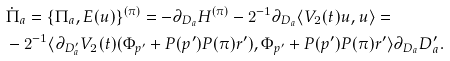<formula> <loc_0><loc_0><loc_500><loc_500>& \dot { \Pi } _ { a } = \{ \Pi _ { a } , E ( u ) \} ^ { ( \pi ) } = - { \partial _ { D _ { a } } } H ^ { ( \pi ) } - 2 ^ { - 1 } \partial _ { D _ { a } } \langle V _ { 2 } ( t ) u , u \rangle = \\ & - 2 ^ { - 1 } \langle \partial _ { D _ { a } ^ { \prime } } V _ { 2 } ( t ) ( \Phi _ { p ^ { \prime } } + P ( p ^ { \prime } ) P ( \pi ) r ^ { \prime } ) , \Phi _ { p ^ { \prime } } + P ( p ^ { \prime } ) P ( \pi ) r ^ { \prime } \rangle { \partial _ { D _ { a } } D _ { a } ^ { \prime } } .</formula> 